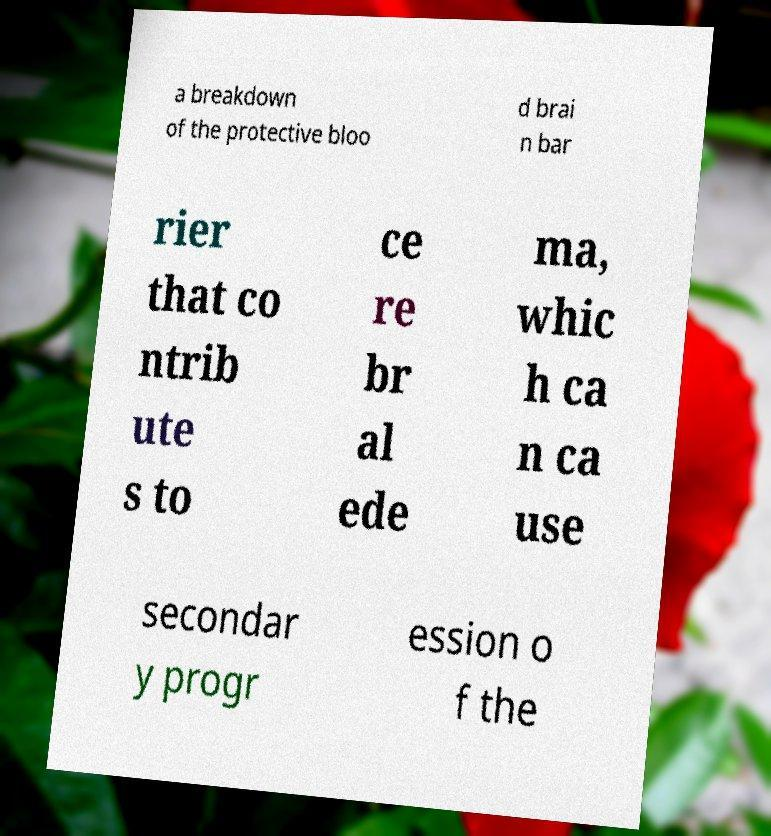Could you assist in decoding the text presented in this image and type it out clearly? a breakdown of the protective bloo d brai n bar rier that co ntrib ute s to ce re br al ede ma, whic h ca n ca use secondar y progr ession o f the 